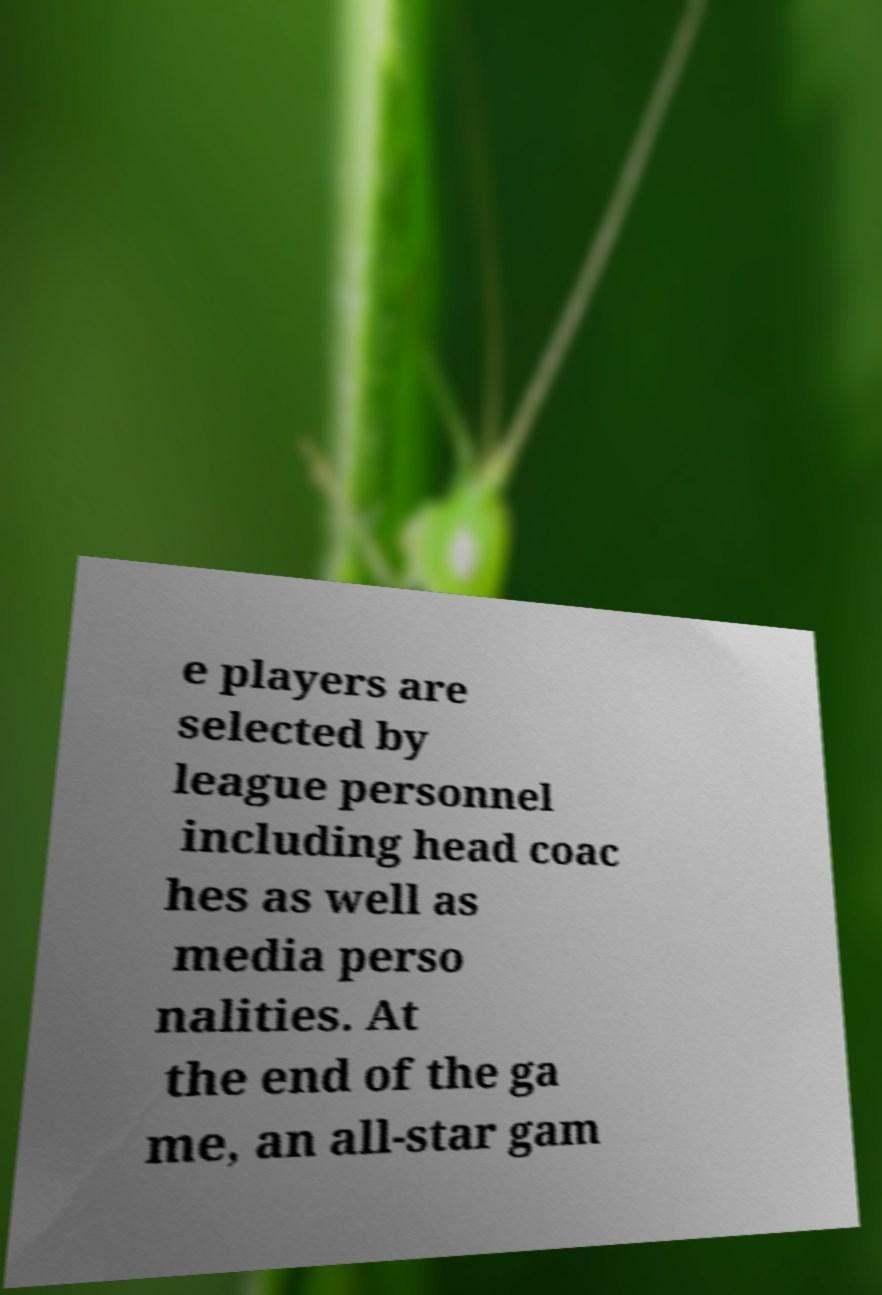Could you assist in decoding the text presented in this image and type it out clearly? e players are selected by league personnel including head coac hes as well as media perso nalities. At the end of the ga me, an all-star gam 